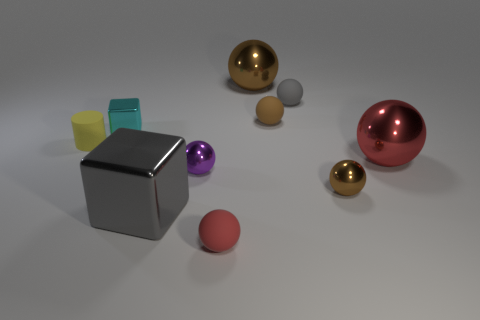Is there any object that stands out or seems dominant in the composition? The large gray cube appears to be the most dominant object due to its size and central positioning. Its metallic surface and angular shape draw attention amidst the other smaller and more colorful round spheres. 